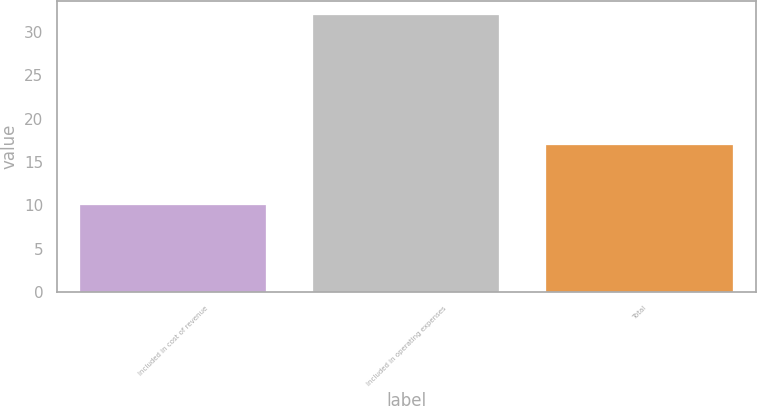<chart> <loc_0><loc_0><loc_500><loc_500><bar_chart><fcel>Included in cost of revenue<fcel>Included in operating expenses<fcel>Total<nl><fcel>10<fcel>32<fcel>17<nl></chart> 